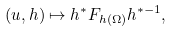Convert formula to latex. <formula><loc_0><loc_0><loc_500><loc_500>( u , h ) \mapsto h ^ { * } F _ { h ( \Omega ) } h ^ { * - 1 } ,</formula> 